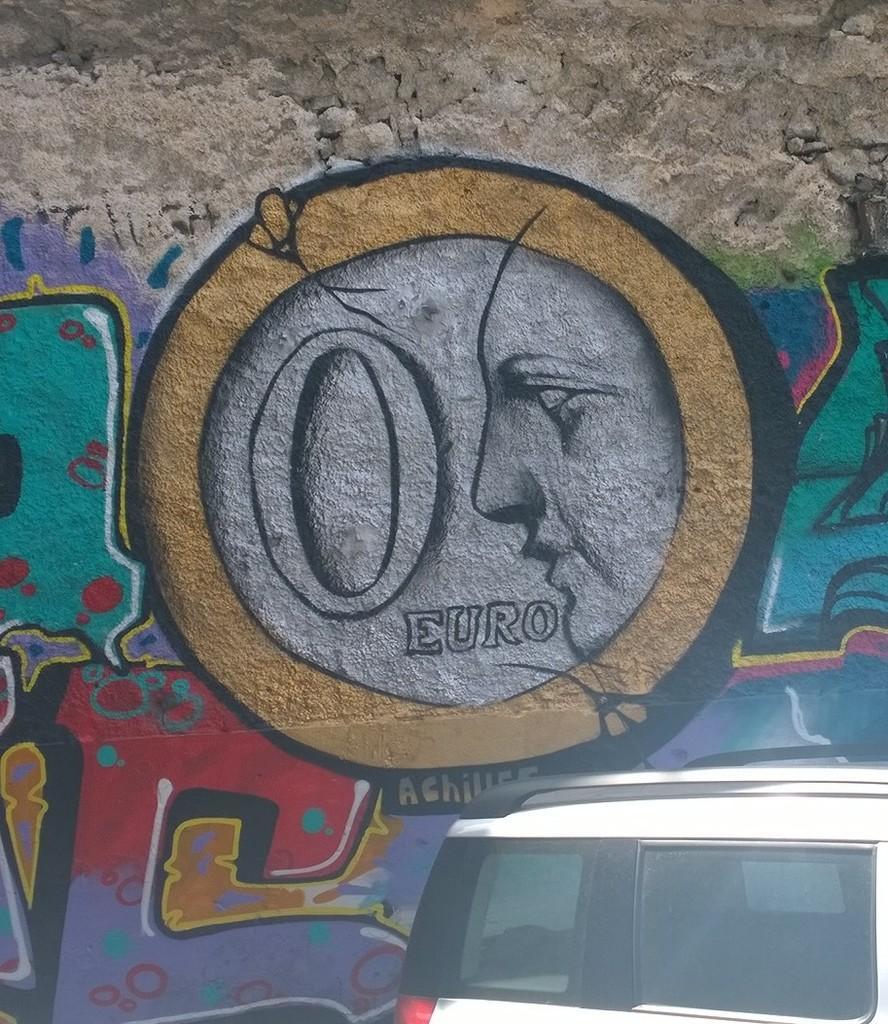Could you give a brief overview of what you see in this image? In this image I can see a wall painting with different colors. I can see a vehicle in white and black color. 